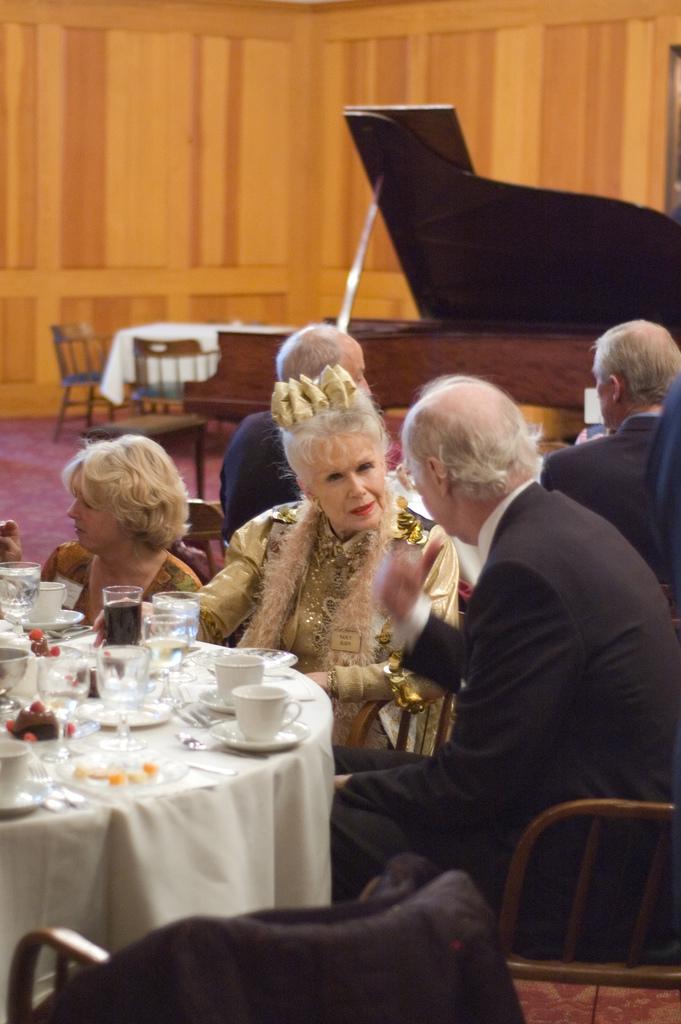Please provide a concise description of this image. This is a picture taken in a room, there are a group of people sitting on a chair in front of this people there is a table covered with cloth on top of the table there is a cup, saucer, glasses and food. Background of this people is a music instrument and a wooden wall. 